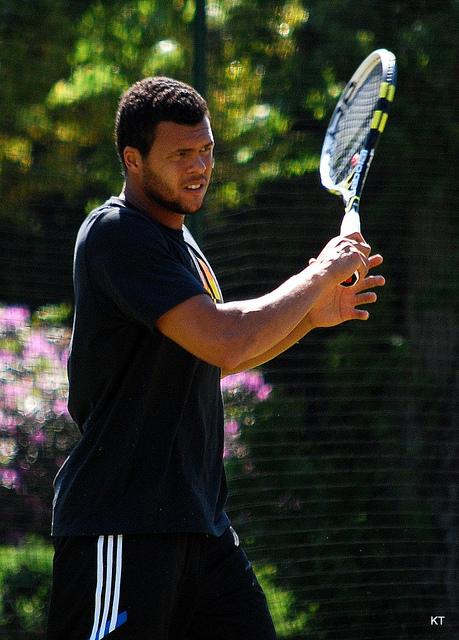Which sport is this?
Answer briefly. Tennis. How many stripes are on the man's pants?
Give a very brief answer. 3. Is this man wearing plaid shorts?
Keep it brief. No. What color is the man wearing?
Be succinct. Black. 